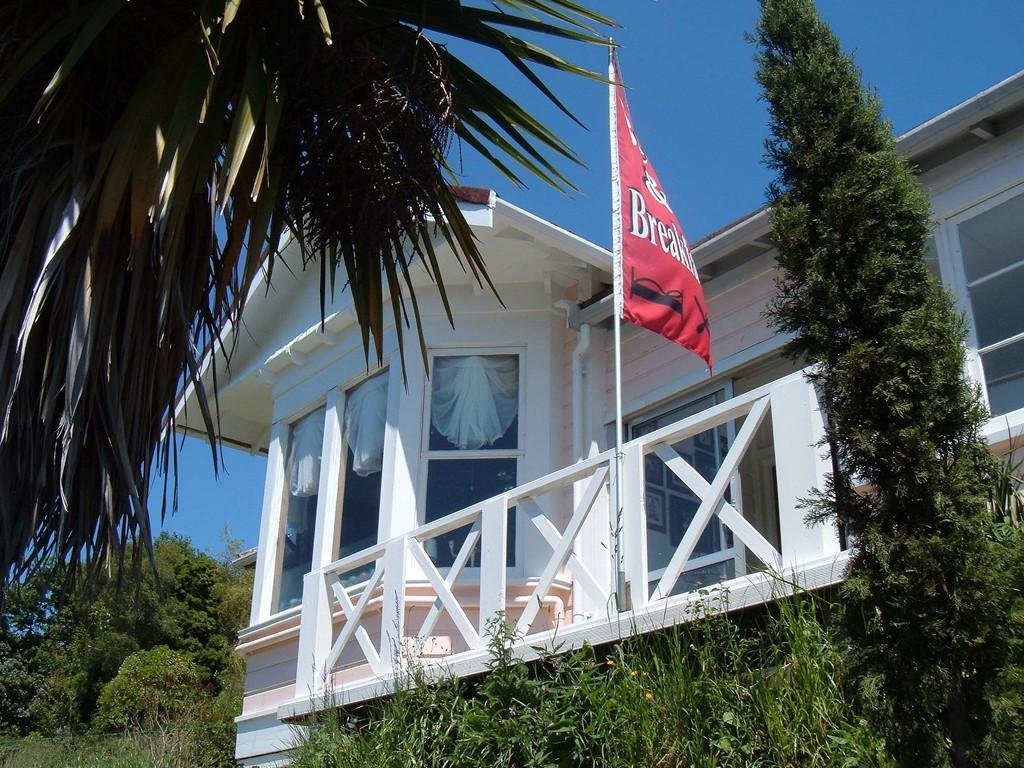Can you describe this image briefly? This image is taken outdoors. At the top of the image there is the sky. At the bottom of the image there are many plants and trees with green leaves. On the left side of the image there is a tree. In the middle of the image there is a building with walls, windows, a door and a roof. There is a flag with a text on it and there is a railing. 